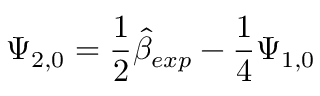<formula> <loc_0><loc_0><loc_500><loc_500>\Psi _ { 2 , 0 } = \frac { 1 } { 2 } \hat { \beta } _ { e x p } - \frac { 1 } { 4 } \Psi _ { 1 , 0 }</formula> 